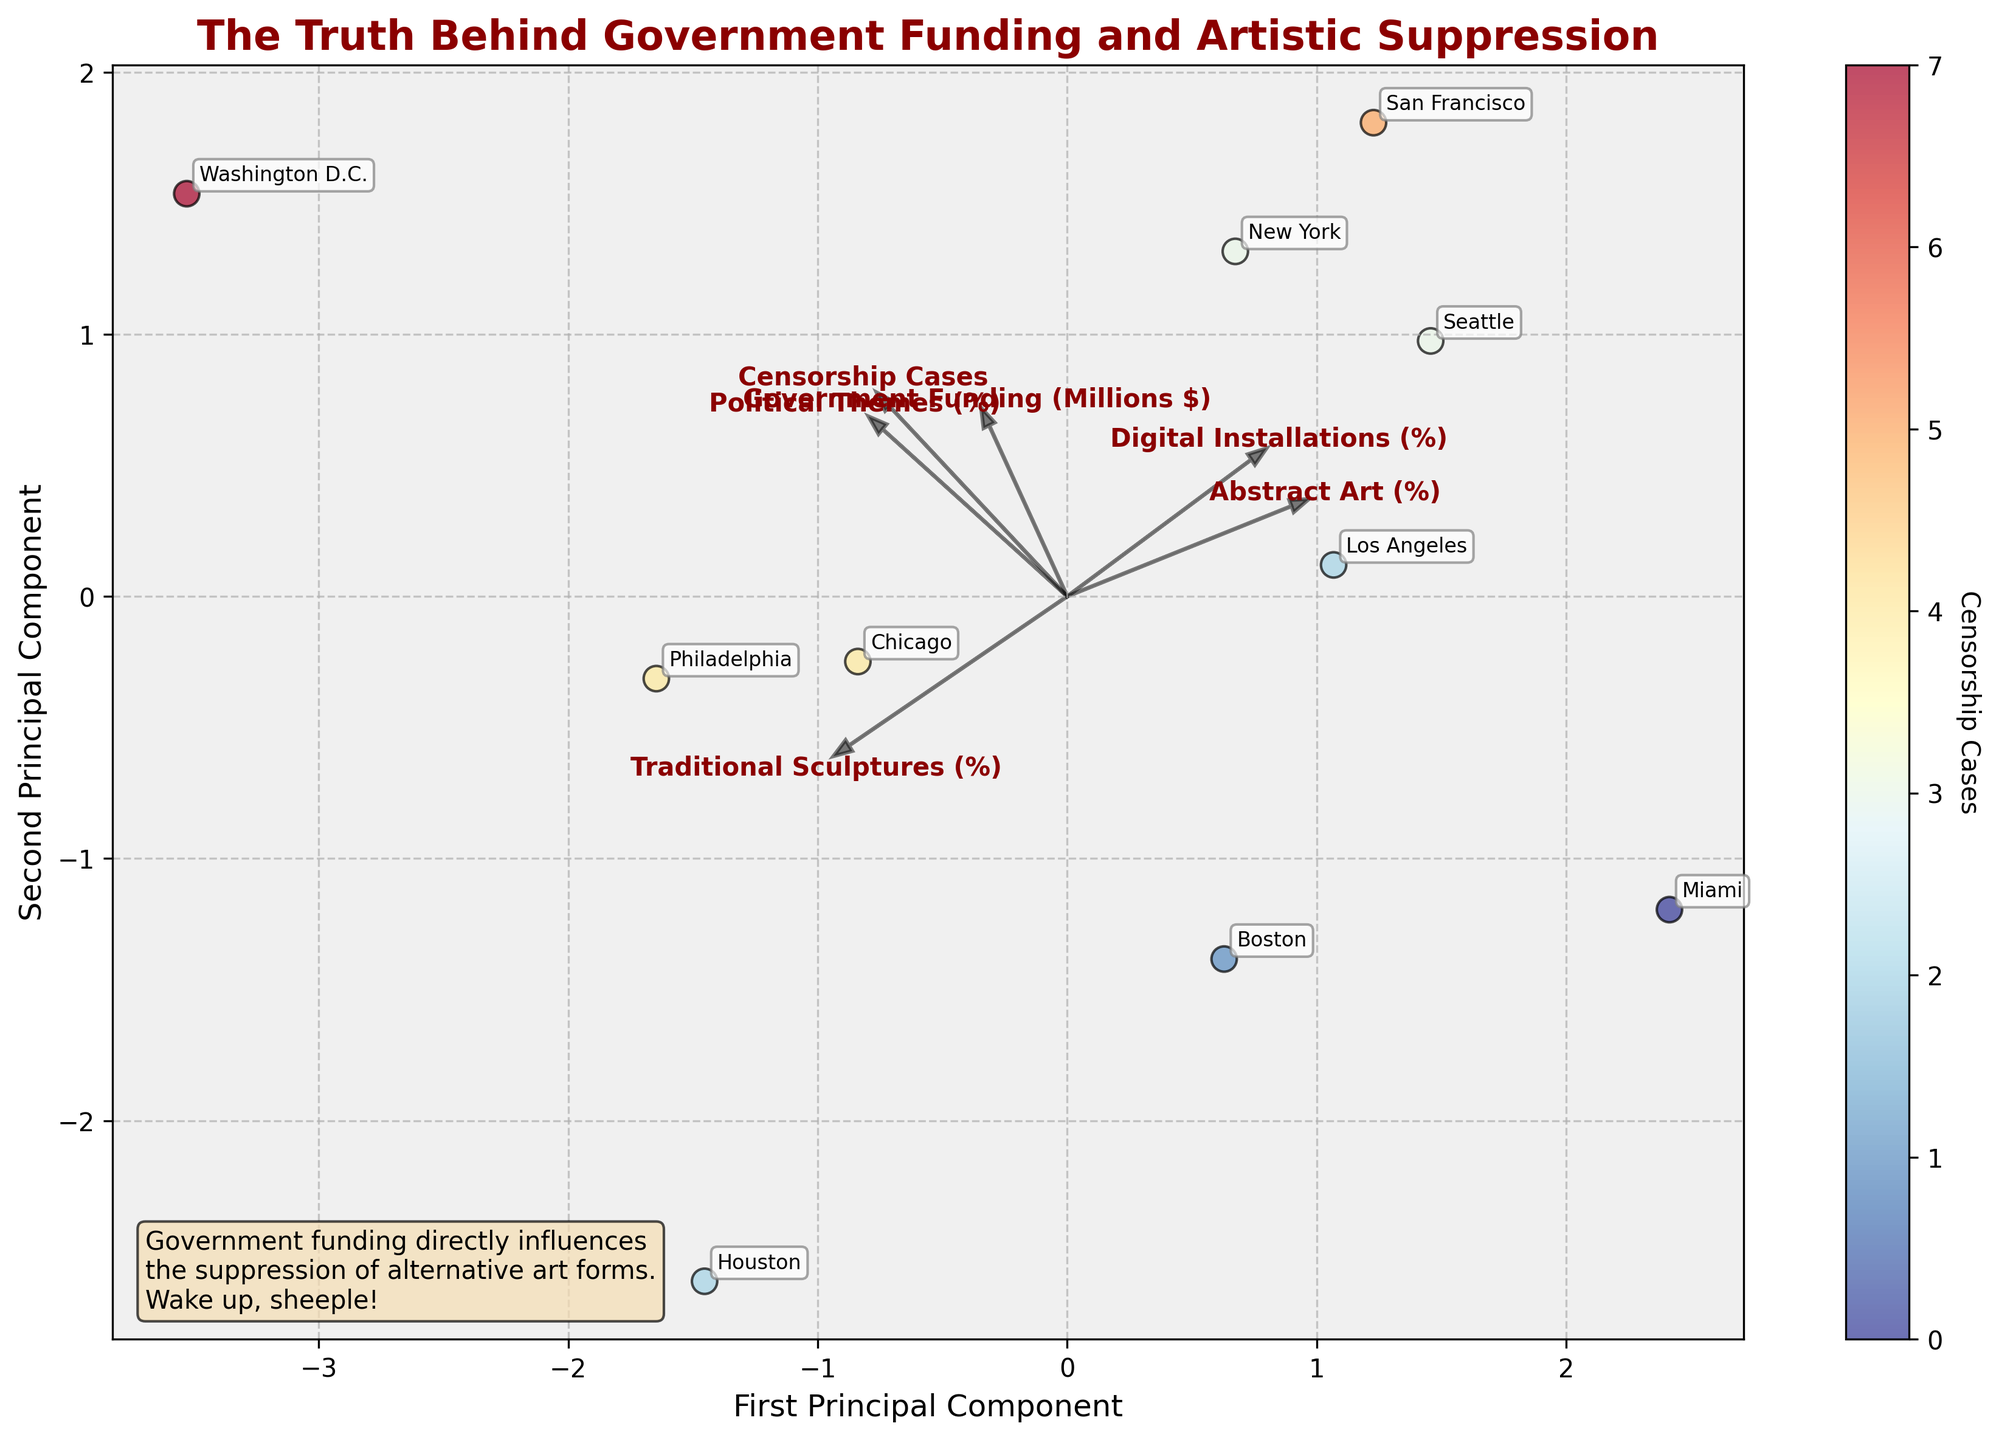What is the title of the plot? The title is displayed prominently at the top of the plot in bold dark red text. It reads "The Truth Behind Government Funding and Artistic Suppression."
Answer: The Truth Behind Government Funding and Artistic Suppression How many cities are included in the biplot? The number of cities can be determined by counting the annotated labels on the plot. There are 10 city names shown (e.g., New York, Los Angeles, Chicago, etc.).
Answer: 10 Which artistic style is most positively correlated with government funding? By examining the direction and length of the loading vector arrows, the arrow for 'Abstract Art (%)' points in a similar direction to 'Government Funding (Millions $)', suggesting a positive correlation.
Answer: Abstract Art (%) Which city has the highest number of censorship cases? The color of the data points indicates censorship cases; Washington D.C. is colored to represent the highest number of cases (7), as seen in the darkest marker.
Answer: Washington D.C Which feature has the strongest influence on the first principal component? The strength of influence is indicated by the length of the arrows on the biplot, with 'Political Themes (%)' having the longest arrow in the direction of the first principal component (x-axis).
Answer: Political Themes (%) How is 'Censorship Cases' associated with the second principal component? The arrow for 'Censorship Cases' points along the negative direction of the second principal component (y-axis), suggesting a negative association.
Answer: Negative association Which city receives the most government funding, and what is its funding amount? The city labels and arrow directions help us see that New York is positioned closest to the arrow for 'Government Funding (Millions $)'), indicating it receives the most funding ($25.5 million).
Answer: New York, $25.5 million Which city has the highest percentage of digital installations? Observing the scatter plot, Seattle is positioned closest to the arrow for 'Digital Installations (%)' indicating it has the highest percentage (35%).
Answer: Seattle Based on the plot, which two cities appear closest to each other? Checking the scatter plot, New York and Washington D.C. are plotted very close to each other in terms of their principal component scores.
Answer: New York and Washington D.C Is there a noticeable trend between 'Traditional Sculptures (%)' and censorship cases? The arrow for 'Traditional Sculptures (%)' points in a similar direction but slightly diverging from 'Censorship Cases,' suggesting a moderate positive trend.
Answer: Moderate positive trend 